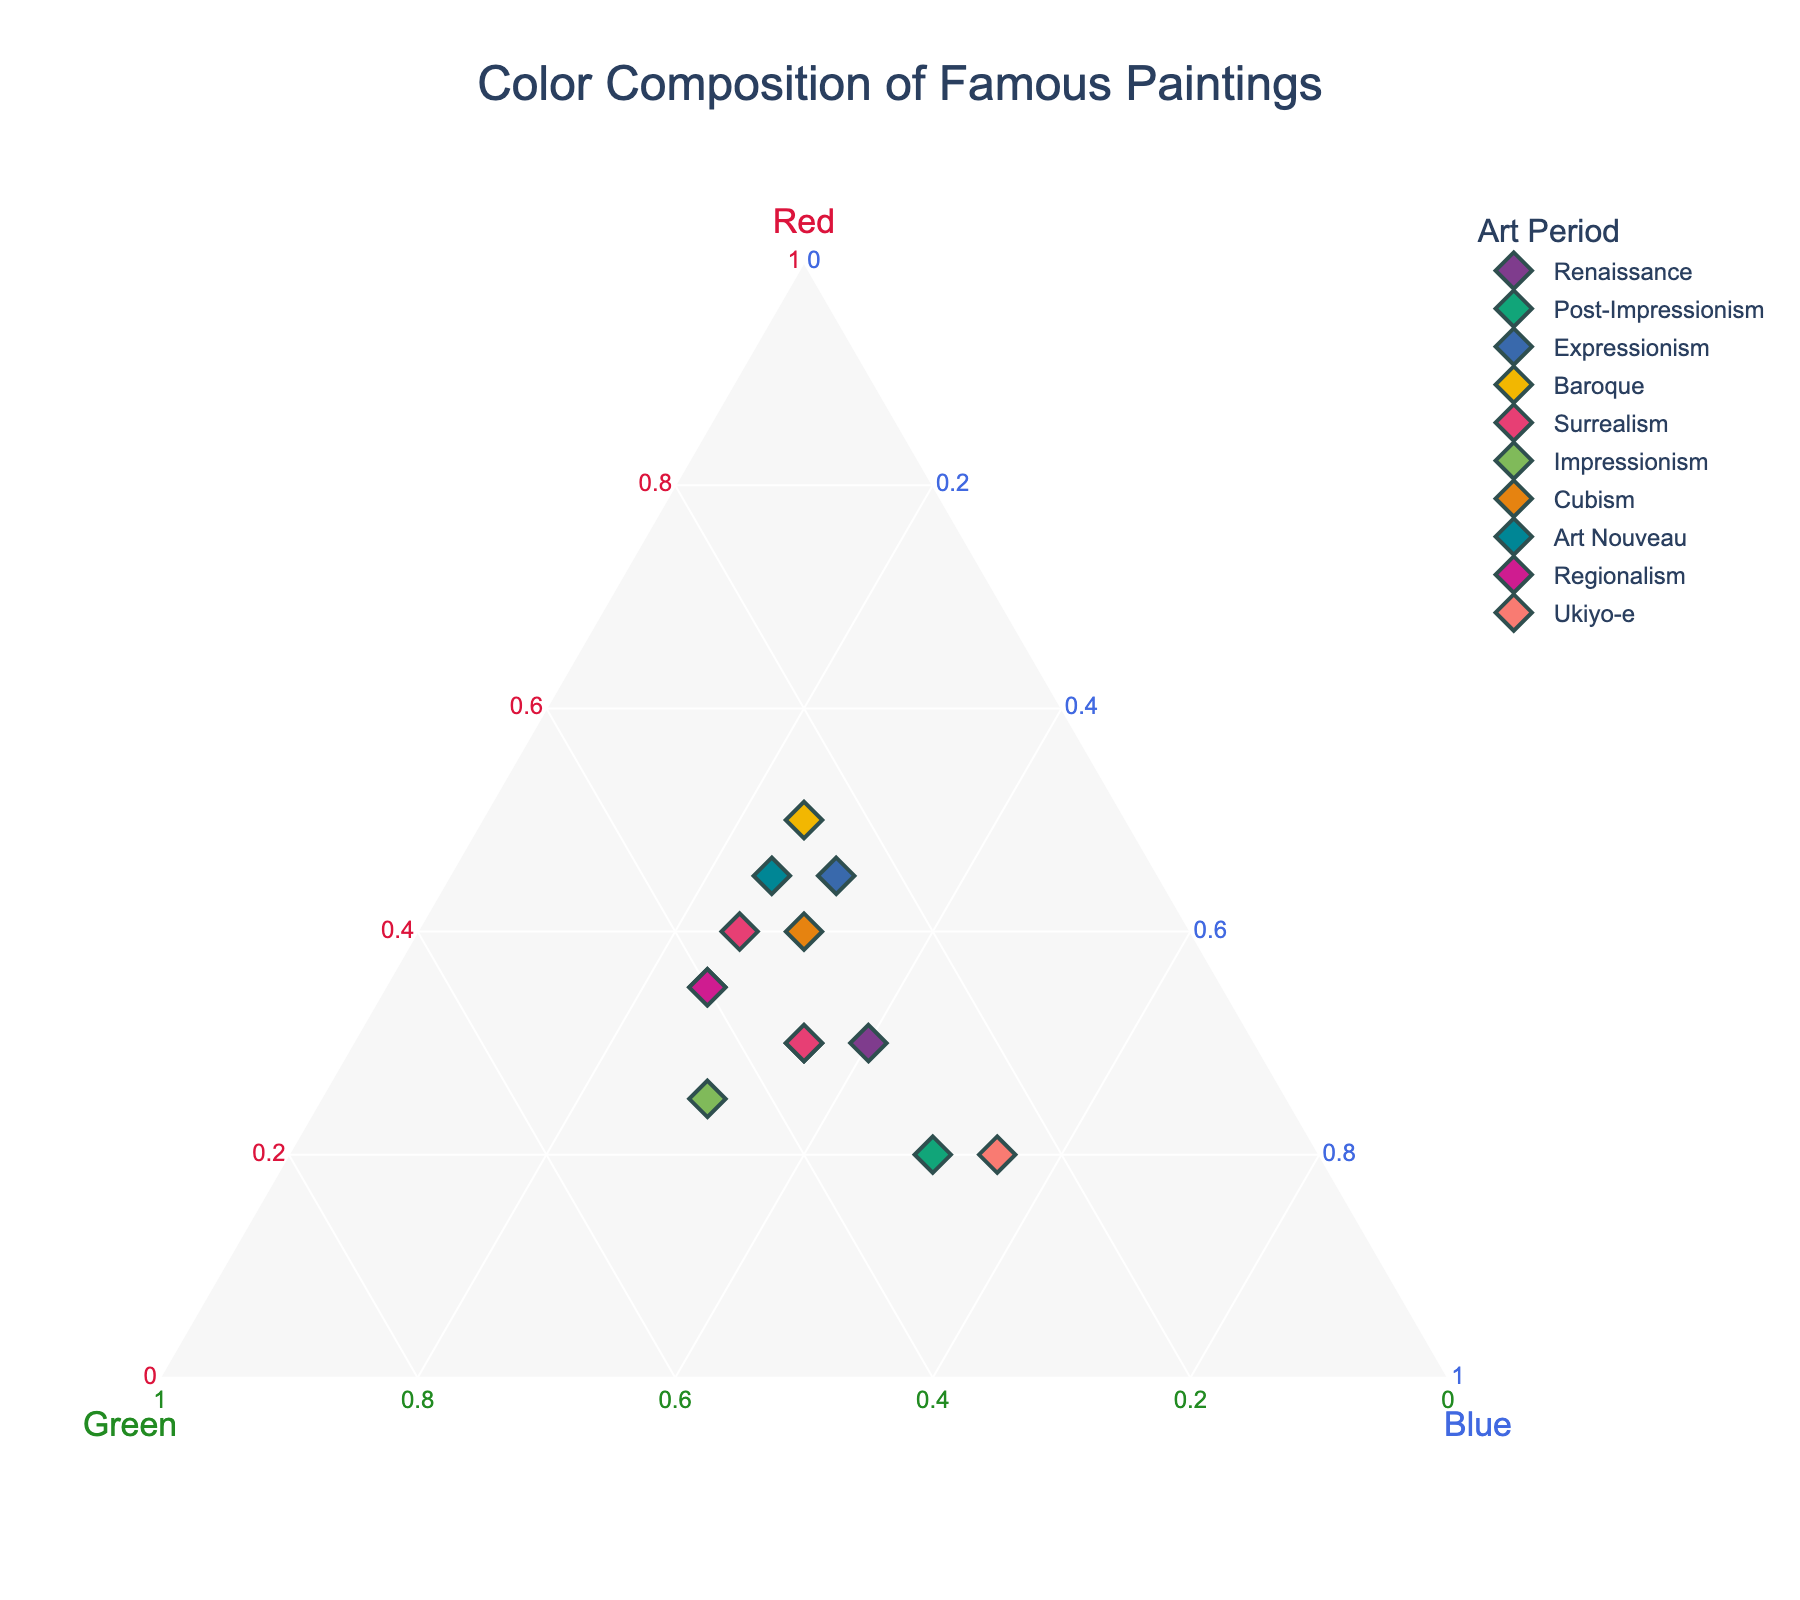What is the title of the plot? The title can be read directly from the top of the plot and it's usually the largest text present.
Answer: Color Composition of Famous Paintings Which painting has the highest proportion of blue? You can locate the highest proportion of blue by finding the data point closest to the blue axis.
Answer: The Great Wave off Kanagawa What is the balance of colors in 'Girl with a Pearl Earring'? Look for the data point representing 'Girl with a Pearl Earring,' and note the proportion of Red, Green, and Blue for that point.
Answer: Red: 30, Green: 35, Blue: 35 Which art period has the most data points in the plot? Look at the legend to identify the colors representing each art period, and then count the corresponding data points in the plot.
Answer: Surrealism How does the color composition of 'Starry Night' compare to 'The Scream'? Look at the proportions of Red, Green, and Blue for both paintings and compare them side by side.
Answer: Starry Night: Red: 20, Green: 30, Blue: 50; The Scream: Red: 45, Green: 25, Blue: 30 Which painting is located closest to the origin of the ternary plot? The origin of a ternary plot is the point where the three axes (Red, Green, and Blue) meet. Locate the data point closest to this point.
Answer: The Night Watch What is the average proportion of Red in the paintings from the Renaissance period? Identify the Renaissance paintings, sum their Red values, and divide by the number of Renaissance paintings to find the average.
Answer: (35 + 30) / 2 = 32.5 Which painting has equal proportions of Green and Blue? Look for a data point where the values for Green and Blue are equal.
Answer: Girl with a Pearl Earring How many paintings have a larger proportion of Red than Blue? Count the number of data points where the Red component is greater than the Blue component.
Answer: Seven What trends can be observed about the use of Green in paintings from different art periods? Observe the different positions of the data points representing each art period along the Green axis to identify potential trends.
Answer: Green is generally more varied across art periods, with Impressionism and Renaissance having higher Green proportions compared to others 